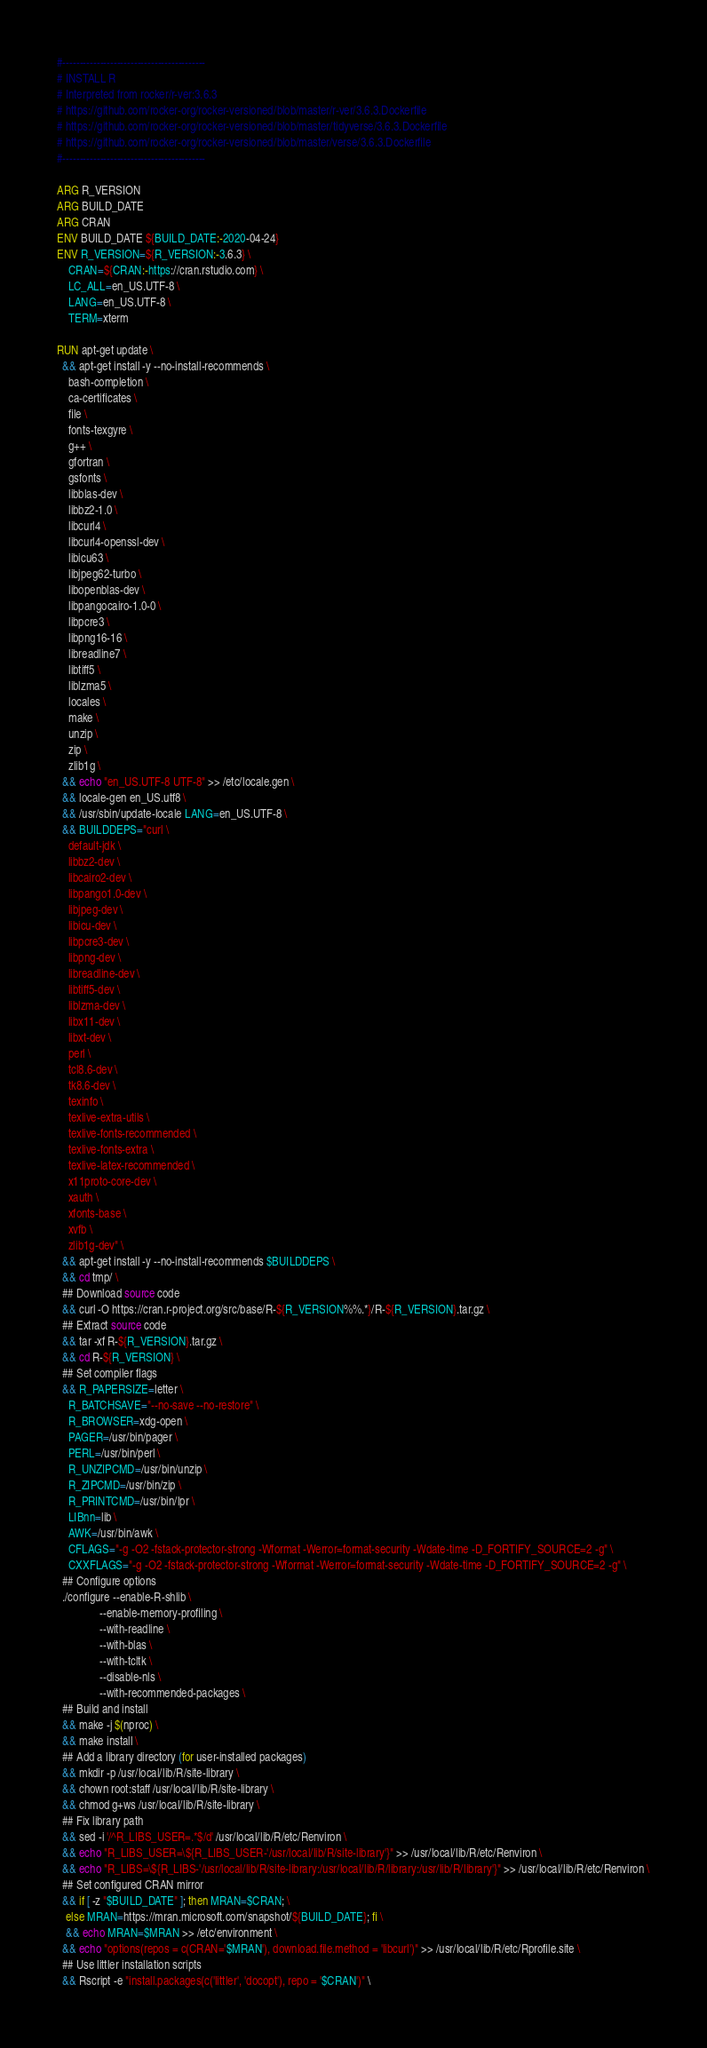Convert code to text. <code><loc_0><loc_0><loc_500><loc_500><_Dockerfile_>#------------------------------------------
# INSTALL R
# Interpreted from rocker/r-ver:3.6.3
# https://github.com/rocker-org/rocker-versioned/blob/master/r-ver/3.6.3.Dockerfile
# https://github.com/rocker-org/rocker-versioned/blob/master/tidyverse/3.6.3.Dockerfile
# https://github.com/rocker-org/rocker-versioned/blob/master/verse/3.6.3.Dockerfile
#------------------------------------------

ARG R_VERSION
ARG BUILD_DATE
ARG CRAN
ENV BUILD_DATE ${BUILD_DATE:-2020-04-24}
ENV R_VERSION=${R_VERSION:-3.6.3} \
    CRAN=${CRAN:-https://cran.rstudio.com} \ 
    LC_ALL=en_US.UTF-8 \
    LANG=en_US.UTF-8 \
    TERM=xterm

RUN apt-get update \
  && apt-get install -y --no-install-recommends \
    bash-completion \
    ca-certificates \
    file \
    fonts-texgyre \
    g++ \
    gfortran \
    gsfonts \
    libblas-dev \
    libbz2-1.0 \
    libcurl4 \
    libcurl4-openssl-dev \
    libicu63 \
    libjpeg62-turbo \
    libopenblas-dev \
    libpangocairo-1.0-0 \
    libpcre3 \
    libpng16-16 \
    libreadline7 \
    libtiff5 \
    liblzma5 \
    locales \
    make \
    unzip \
    zip \
    zlib1g \
  && echo "en_US.UTF-8 UTF-8" >> /etc/locale.gen \
  && locale-gen en_US.utf8 \
  && /usr/sbin/update-locale LANG=en_US.UTF-8 \
  && BUILDDEPS="curl \
    default-jdk \
    libbz2-dev \
    libcairo2-dev \
    libpango1.0-dev \
    libjpeg-dev \
    libicu-dev \
    libpcre3-dev \
    libpng-dev \
    libreadline-dev \
    libtiff5-dev \
    liblzma-dev \
    libx11-dev \
    libxt-dev \
    perl \
    tcl8.6-dev \
    tk8.6-dev \
    texinfo \
    texlive-extra-utils \
    texlive-fonts-recommended \
    texlive-fonts-extra \
    texlive-latex-recommended \
    x11proto-core-dev \
    xauth \
    xfonts-base \
    xvfb \
    zlib1g-dev" \
  && apt-get install -y --no-install-recommends $BUILDDEPS \
  && cd tmp/ \
  ## Download source code
  && curl -O https://cran.r-project.org/src/base/R-${R_VERSION%%.*}/R-${R_VERSION}.tar.gz \
  ## Extract source code
  && tar -xf R-${R_VERSION}.tar.gz \
  && cd R-${R_VERSION} \
  ## Set compiler flags
  && R_PAPERSIZE=letter \
    R_BATCHSAVE="--no-save --no-restore" \
    R_BROWSER=xdg-open \
    PAGER=/usr/bin/pager \
    PERL=/usr/bin/perl \
    R_UNZIPCMD=/usr/bin/unzip \
    R_ZIPCMD=/usr/bin/zip \
    R_PRINTCMD=/usr/bin/lpr \
    LIBnn=lib \
    AWK=/usr/bin/awk \
    CFLAGS="-g -O2 -fstack-protector-strong -Wformat -Werror=format-security -Wdate-time -D_FORTIFY_SOURCE=2 -g" \
    CXXFLAGS="-g -O2 -fstack-protector-strong -Wformat -Werror=format-security -Wdate-time -D_FORTIFY_SOURCE=2 -g" \
  ## Configure options
  ./configure --enable-R-shlib \
               --enable-memory-profiling \
               --with-readline \
               --with-blas \
               --with-tcltk \
               --disable-nls \
               --with-recommended-packages \
  ## Build and install
  && make -j $(nproc) \
  && make install \
  ## Add a library directory (for user-installed packages)
  && mkdir -p /usr/local/lib/R/site-library \
  && chown root:staff /usr/local/lib/R/site-library \
  && chmod g+ws /usr/local/lib/R/site-library \
  ## Fix library path
  && sed -i '/^R_LIBS_USER=.*$/d' /usr/local/lib/R/etc/Renviron \
  && echo "R_LIBS_USER=\${R_LIBS_USER-'/usr/local/lib/R/site-library'}" >> /usr/local/lib/R/etc/Renviron \
  && echo "R_LIBS=\${R_LIBS-'/usr/local/lib/R/site-library:/usr/local/lib/R/library:/usr/lib/R/library'}" >> /usr/local/lib/R/etc/Renviron \
  ## Set configured CRAN mirror
  && if [ -z "$BUILD_DATE" ]; then MRAN=$CRAN; \
   else MRAN=https://mran.microsoft.com/snapshot/${BUILD_DATE}; fi \
   && echo MRAN=$MRAN >> /etc/environment \
  && echo "options(repos = c(CRAN='$MRAN'), download.file.method = 'libcurl')" >> /usr/local/lib/R/etc/Rprofile.site \
  ## Use littler installation scripts
  && Rscript -e "install.packages(c('littler', 'docopt'), repo = '$CRAN')" \</code> 